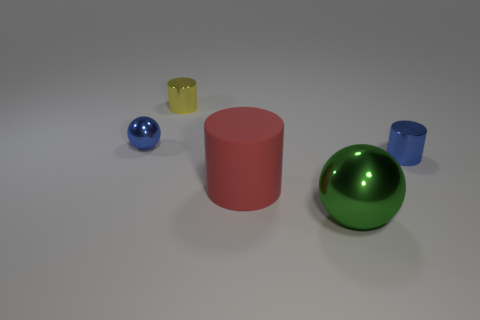What number of green balls have the same size as the matte object? 1 